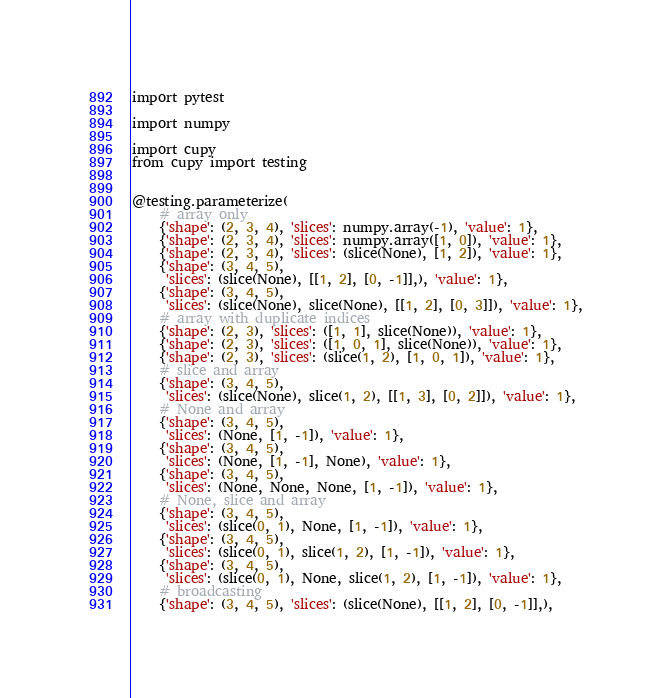Convert code to text. <code><loc_0><loc_0><loc_500><loc_500><_Python_>import pytest

import numpy

import cupy
from cupy import testing


@testing.parameterize(
    # array only
    {'shape': (2, 3, 4), 'slices': numpy.array(-1), 'value': 1},
    {'shape': (2, 3, 4), 'slices': numpy.array([1, 0]), 'value': 1},
    {'shape': (2, 3, 4), 'slices': (slice(None), [1, 2]), 'value': 1},
    {'shape': (3, 4, 5),
     'slices': (slice(None), [[1, 2], [0, -1]],), 'value': 1},
    {'shape': (3, 4, 5),
     'slices': (slice(None), slice(None), [[1, 2], [0, 3]]), 'value': 1},
    # array with duplicate indices
    {'shape': (2, 3), 'slices': ([1, 1], slice(None)), 'value': 1},
    {'shape': (2, 3), 'slices': ([1, 0, 1], slice(None)), 'value': 1},
    {'shape': (2, 3), 'slices': (slice(1, 2), [1, 0, 1]), 'value': 1},
    # slice and array
    {'shape': (3, 4, 5),
     'slices': (slice(None), slice(1, 2), [[1, 3], [0, 2]]), 'value': 1},
    # None and array
    {'shape': (3, 4, 5),
     'slices': (None, [1, -1]), 'value': 1},
    {'shape': (3, 4, 5),
     'slices': (None, [1, -1], None), 'value': 1},
    {'shape': (3, 4, 5),
     'slices': (None, None, None, [1, -1]), 'value': 1},
    # None, slice and array
    {'shape': (3, 4, 5),
     'slices': (slice(0, 1), None, [1, -1]), 'value': 1},
    {'shape': (3, 4, 5),
     'slices': (slice(0, 1), slice(1, 2), [1, -1]), 'value': 1},
    {'shape': (3, 4, 5),
     'slices': (slice(0, 1), None, slice(1, 2), [1, -1]), 'value': 1},
    # broadcasting
    {'shape': (3, 4, 5), 'slices': (slice(None), [[1, 2], [0, -1]],),</code> 